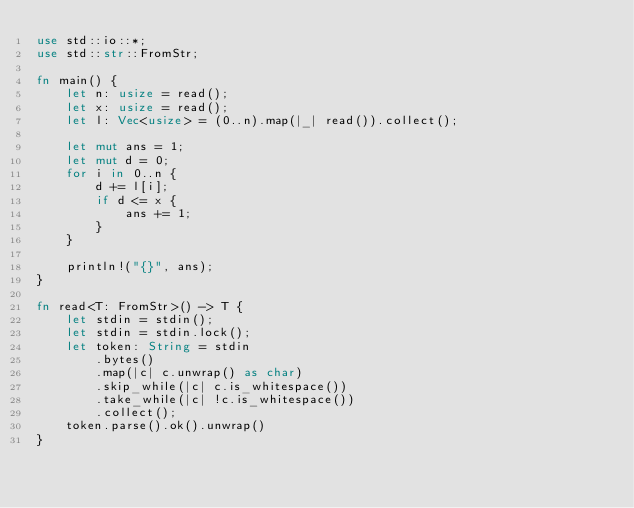<code> <loc_0><loc_0><loc_500><loc_500><_Rust_>use std::io::*;
use std::str::FromStr;

fn main() {
    let n: usize = read();
    let x: usize = read();
    let l: Vec<usize> = (0..n).map(|_| read()).collect();
    
    let mut ans = 1;
    let mut d = 0;
    for i in 0..n {
        d += l[i];
        if d <= x {
            ans += 1;
        }
    }

    println!("{}", ans);
}

fn read<T: FromStr>() -> T {
    let stdin = stdin();
    let stdin = stdin.lock();
    let token: String = stdin
        .bytes()
        .map(|c| c.unwrap() as char)
        .skip_while(|c| c.is_whitespace())
        .take_while(|c| !c.is_whitespace())
        .collect();
    token.parse().ok().unwrap()
}
</code> 